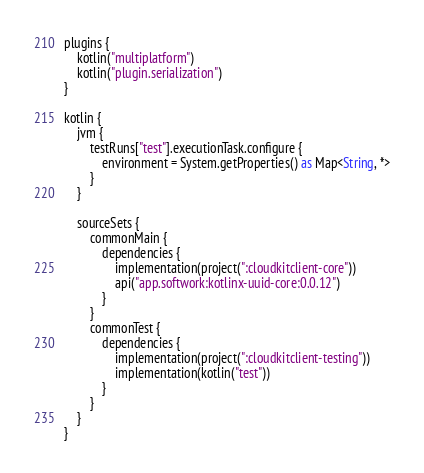Convert code to text. <code><loc_0><loc_0><loc_500><loc_500><_Kotlin_>plugins {
    kotlin("multiplatform")
    kotlin("plugin.serialization")
}

kotlin {
    jvm {
        testRuns["test"].executionTask.configure {
            environment = System.getProperties() as Map<String, *>
        }
    }

    sourceSets {
        commonMain {
            dependencies {
                implementation(project(":cloudkitclient-core"))
                api("app.softwork:kotlinx-uuid-core:0.0.12")
            }
        }
        commonTest {
            dependencies {
                implementation(project(":cloudkitclient-testing"))
                implementation(kotlin("test"))
            }
        }
    }
}
</code> 